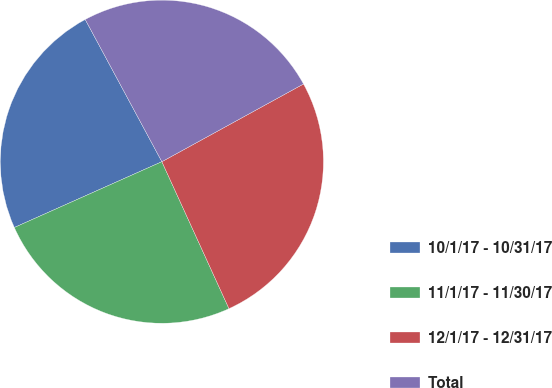Convert chart. <chart><loc_0><loc_0><loc_500><loc_500><pie_chart><fcel>10/1/17 - 10/31/17<fcel>11/1/17 - 11/30/17<fcel>12/1/17 - 12/31/17<fcel>Total<nl><fcel>23.81%<fcel>25.14%<fcel>26.17%<fcel>24.88%<nl></chart> 